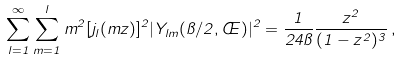Convert formula to latex. <formula><loc_0><loc_0><loc_500><loc_500>\sum _ { l = 1 } ^ { \infty } \sum _ { m = 1 } ^ { l } m ^ { 2 } [ j _ { l } ( m z ) ] ^ { 2 } | Y _ { l m } ( \pi / 2 , \phi ) | ^ { 2 } = \frac { 1 } { 2 4 \pi } \frac { z ^ { 2 } } { ( 1 - z ^ { 2 } ) ^ { 3 } } \, ,</formula> 